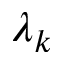<formula> <loc_0><loc_0><loc_500><loc_500>\lambda _ { k }</formula> 